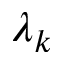<formula> <loc_0><loc_0><loc_500><loc_500>\lambda _ { k }</formula> 